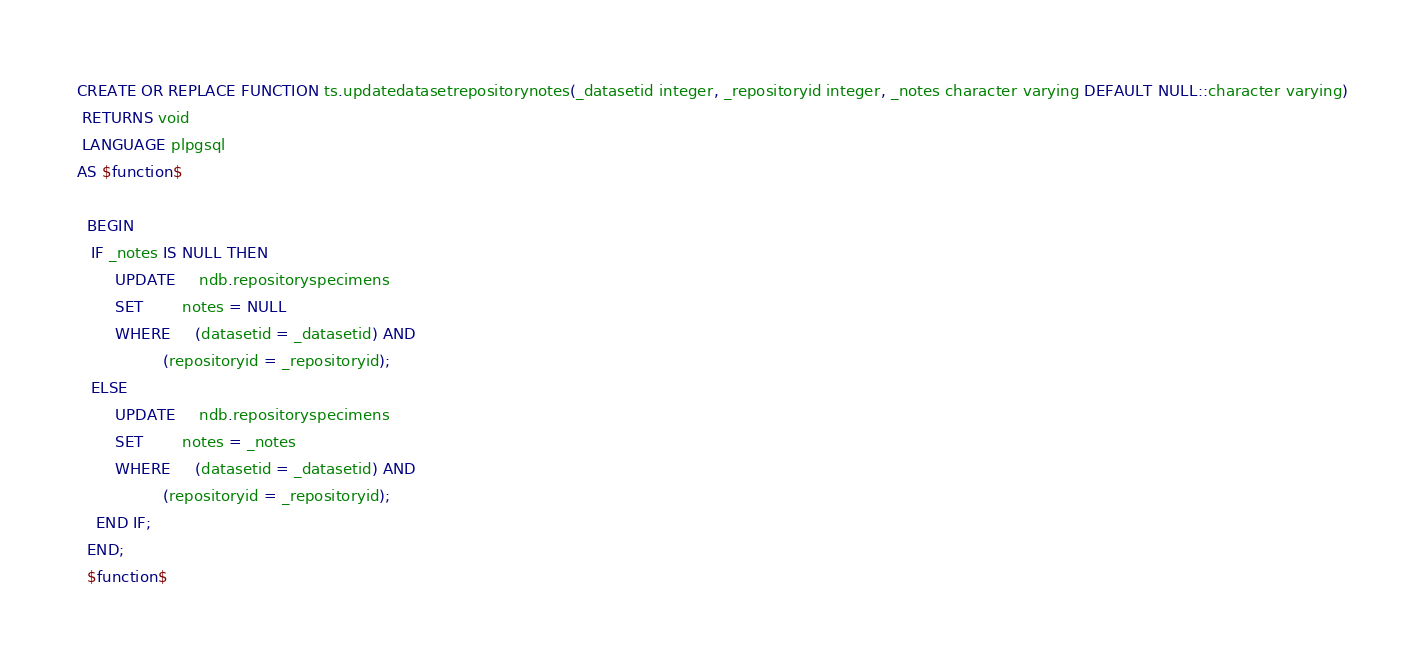Convert code to text. <code><loc_0><loc_0><loc_500><loc_500><_SQL_>CREATE OR REPLACE FUNCTION ts.updatedatasetrepositorynotes(_datasetid integer, _repositoryid integer, _notes character varying DEFAULT NULL::character varying)
 RETURNS void
 LANGUAGE plpgsql
AS $function$

  BEGIN
   IF _notes IS NULL THEN
        UPDATE     ndb.repositoryspecimens
        SET        notes = NULL
        WHERE     (datasetid = _datasetid) AND
                  (repositoryid = _repositoryid);
   ELSE
        UPDATE     ndb.repositoryspecimens
        SET        notes = _notes
        WHERE     (datasetid = _datasetid) AND
                  (repositoryid = _repositoryid);
    END IF;
  END;
  $function$
</code> 